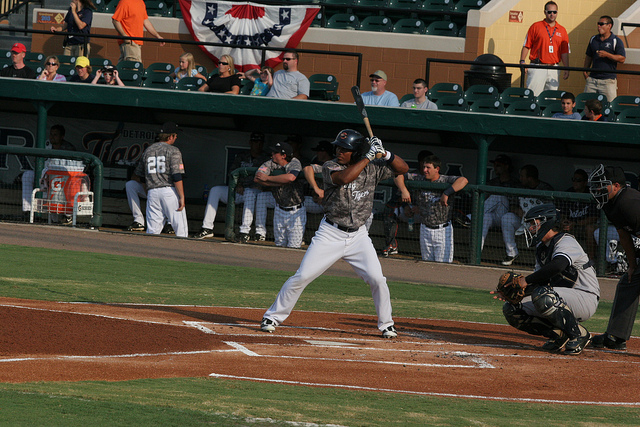Please identify all text content in this image. 26 R G 